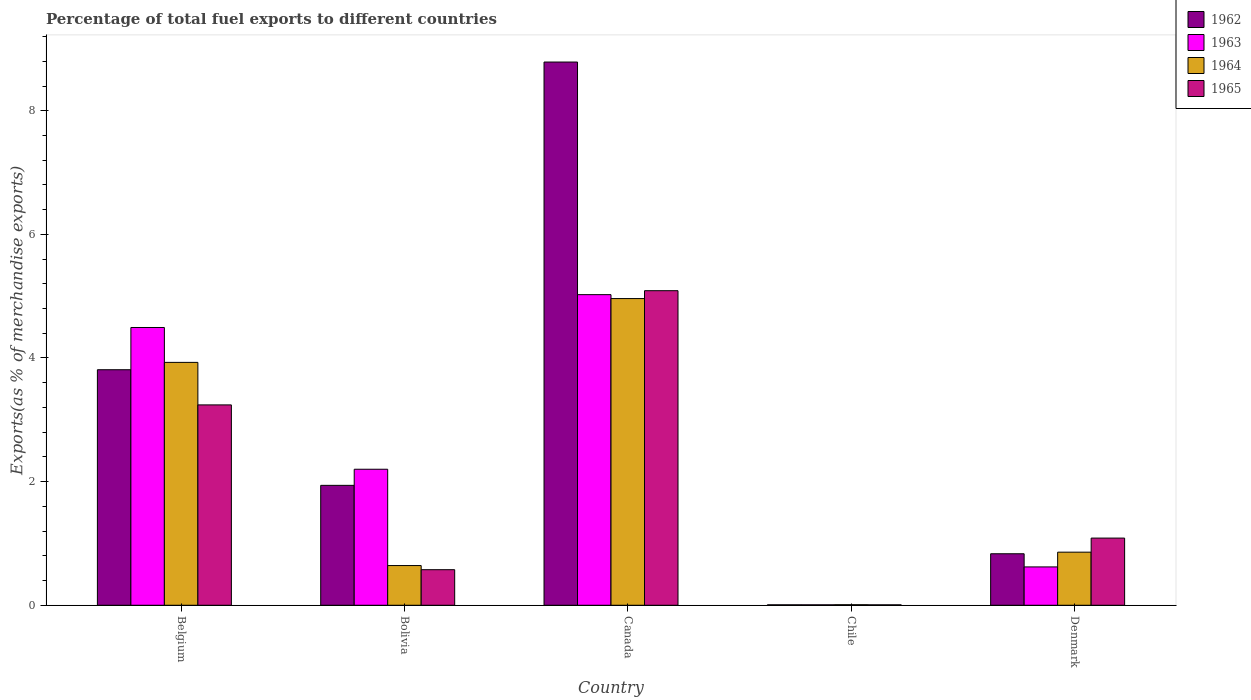How many different coloured bars are there?
Your answer should be compact. 4. How many groups of bars are there?
Your response must be concise. 5. Are the number of bars per tick equal to the number of legend labels?
Give a very brief answer. Yes. How many bars are there on the 2nd tick from the left?
Provide a succinct answer. 4. In how many cases, is the number of bars for a given country not equal to the number of legend labels?
Keep it short and to the point. 0. What is the percentage of exports to different countries in 1964 in Chile?
Offer a very short reply. 0.01. Across all countries, what is the maximum percentage of exports to different countries in 1964?
Your answer should be very brief. 4.96. Across all countries, what is the minimum percentage of exports to different countries in 1964?
Your response must be concise. 0.01. What is the total percentage of exports to different countries in 1963 in the graph?
Provide a short and direct response. 12.35. What is the difference between the percentage of exports to different countries in 1965 in Canada and that in Chile?
Offer a very short reply. 5.08. What is the difference between the percentage of exports to different countries in 1963 in Bolivia and the percentage of exports to different countries in 1964 in Denmark?
Your answer should be very brief. 1.34. What is the average percentage of exports to different countries in 1964 per country?
Give a very brief answer. 2.08. What is the difference between the percentage of exports to different countries of/in 1963 and percentage of exports to different countries of/in 1962 in Chile?
Offer a terse response. 7.908928153989043e-5. What is the ratio of the percentage of exports to different countries in 1964 in Belgium to that in Bolivia?
Your response must be concise. 6.12. Is the percentage of exports to different countries in 1962 in Belgium less than that in Bolivia?
Your answer should be very brief. No. What is the difference between the highest and the second highest percentage of exports to different countries in 1962?
Keep it short and to the point. 6.85. What is the difference between the highest and the lowest percentage of exports to different countries in 1964?
Ensure brevity in your answer.  4.95. Is the sum of the percentage of exports to different countries in 1962 in Bolivia and Canada greater than the maximum percentage of exports to different countries in 1964 across all countries?
Make the answer very short. Yes. How many countries are there in the graph?
Offer a very short reply. 5. Does the graph contain any zero values?
Ensure brevity in your answer.  No. Does the graph contain grids?
Provide a succinct answer. No. Where does the legend appear in the graph?
Provide a succinct answer. Top right. How many legend labels are there?
Provide a succinct answer. 4. What is the title of the graph?
Your answer should be very brief. Percentage of total fuel exports to different countries. What is the label or title of the X-axis?
Offer a very short reply. Country. What is the label or title of the Y-axis?
Offer a very short reply. Exports(as % of merchandise exports). What is the Exports(as % of merchandise exports) of 1962 in Belgium?
Offer a very short reply. 3.81. What is the Exports(as % of merchandise exports) in 1963 in Belgium?
Make the answer very short. 4.49. What is the Exports(as % of merchandise exports) in 1964 in Belgium?
Your answer should be compact. 3.93. What is the Exports(as % of merchandise exports) of 1965 in Belgium?
Keep it short and to the point. 3.24. What is the Exports(as % of merchandise exports) in 1962 in Bolivia?
Give a very brief answer. 1.94. What is the Exports(as % of merchandise exports) of 1963 in Bolivia?
Ensure brevity in your answer.  2.2. What is the Exports(as % of merchandise exports) of 1964 in Bolivia?
Make the answer very short. 0.64. What is the Exports(as % of merchandise exports) of 1965 in Bolivia?
Ensure brevity in your answer.  0.58. What is the Exports(as % of merchandise exports) of 1962 in Canada?
Give a very brief answer. 8.79. What is the Exports(as % of merchandise exports) in 1963 in Canada?
Provide a short and direct response. 5.02. What is the Exports(as % of merchandise exports) of 1964 in Canada?
Your response must be concise. 4.96. What is the Exports(as % of merchandise exports) of 1965 in Canada?
Offer a terse response. 5.09. What is the Exports(as % of merchandise exports) in 1962 in Chile?
Ensure brevity in your answer.  0.01. What is the Exports(as % of merchandise exports) of 1963 in Chile?
Keep it short and to the point. 0.01. What is the Exports(as % of merchandise exports) of 1964 in Chile?
Provide a succinct answer. 0.01. What is the Exports(as % of merchandise exports) of 1965 in Chile?
Offer a very short reply. 0.01. What is the Exports(as % of merchandise exports) in 1962 in Denmark?
Your response must be concise. 0.83. What is the Exports(as % of merchandise exports) in 1963 in Denmark?
Offer a terse response. 0.62. What is the Exports(as % of merchandise exports) of 1964 in Denmark?
Make the answer very short. 0.86. What is the Exports(as % of merchandise exports) in 1965 in Denmark?
Offer a very short reply. 1.09. Across all countries, what is the maximum Exports(as % of merchandise exports) of 1962?
Offer a terse response. 8.79. Across all countries, what is the maximum Exports(as % of merchandise exports) in 1963?
Make the answer very short. 5.02. Across all countries, what is the maximum Exports(as % of merchandise exports) in 1964?
Ensure brevity in your answer.  4.96. Across all countries, what is the maximum Exports(as % of merchandise exports) in 1965?
Keep it short and to the point. 5.09. Across all countries, what is the minimum Exports(as % of merchandise exports) in 1962?
Provide a short and direct response. 0.01. Across all countries, what is the minimum Exports(as % of merchandise exports) of 1963?
Provide a short and direct response. 0.01. Across all countries, what is the minimum Exports(as % of merchandise exports) of 1964?
Make the answer very short. 0.01. Across all countries, what is the minimum Exports(as % of merchandise exports) in 1965?
Your response must be concise. 0.01. What is the total Exports(as % of merchandise exports) of 1962 in the graph?
Give a very brief answer. 15.38. What is the total Exports(as % of merchandise exports) in 1963 in the graph?
Provide a short and direct response. 12.35. What is the total Exports(as % of merchandise exports) of 1964 in the graph?
Ensure brevity in your answer.  10.4. What is the total Exports(as % of merchandise exports) in 1965 in the graph?
Make the answer very short. 10. What is the difference between the Exports(as % of merchandise exports) of 1962 in Belgium and that in Bolivia?
Provide a short and direct response. 1.87. What is the difference between the Exports(as % of merchandise exports) of 1963 in Belgium and that in Bolivia?
Offer a very short reply. 2.29. What is the difference between the Exports(as % of merchandise exports) in 1964 in Belgium and that in Bolivia?
Your response must be concise. 3.29. What is the difference between the Exports(as % of merchandise exports) of 1965 in Belgium and that in Bolivia?
Provide a succinct answer. 2.67. What is the difference between the Exports(as % of merchandise exports) in 1962 in Belgium and that in Canada?
Keep it short and to the point. -4.98. What is the difference between the Exports(as % of merchandise exports) in 1963 in Belgium and that in Canada?
Ensure brevity in your answer.  -0.53. What is the difference between the Exports(as % of merchandise exports) of 1964 in Belgium and that in Canada?
Keep it short and to the point. -1.03. What is the difference between the Exports(as % of merchandise exports) in 1965 in Belgium and that in Canada?
Give a very brief answer. -1.85. What is the difference between the Exports(as % of merchandise exports) in 1962 in Belgium and that in Chile?
Your answer should be compact. 3.8. What is the difference between the Exports(as % of merchandise exports) of 1963 in Belgium and that in Chile?
Give a very brief answer. 4.49. What is the difference between the Exports(as % of merchandise exports) in 1964 in Belgium and that in Chile?
Give a very brief answer. 3.92. What is the difference between the Exports(as % of merchandise exports) in 1965 in Belgium and that in Chile?
Make the answer very short. 3.23. What is the difference between the Exports(as % of merchandise exports) of 1962 in Belgium and that in Denmark?
Your answer should be very brief. 2.98. What is the difference between the Exports(as % of merchandise exports) in 1963 in Belgium and that in Denmark?
Offer a very short reply. 3.87. What is the difference between the Exports(as % of merchandise exports) in 1964 in Belgium and that in Denmark?
Ensure brevity in your answer.  3.07. What is the difference between the Exports(as % of merchandise exports) in 1965 in Belgium and that in Denmark?
Your answer should be compact. 2.15. What is the difference between the Exports(as % of merchandise exports) of 1962 in Bolivia and that in Canada?
Provide a succinct answer. -6.85. What is the difference between the Exports(as % of merchandise exports) of 1963 in Bolivia and that in Canada?
Give a very brief answer. -2.82. What is the difference between the Exports(as % of merchandise exports) of 1964 in Bolivia and that in Canada?
Your answer should be very brief. -4.32. What is the difference between the Exports(as % of merchandise exports) in 1965 in Bolivia and that in Canada?
Give a very brief answer. -4.51. What is the difference between the Exports(as % of merchandise exports) in 1962 in Bolivia and that in Chile?
Offer a very short reply. 1.93. What is the difference between the Exports(as % of merchandise exports) in 1963 in Bolivia and that in Chile?
Offer a very short reply. 2.19. What is the difference between the Exports(as % of merchandise exports) in 1964 in Bolivia and that in Chile?
Offer a terse response. 0.63. What is the difference between the Exports(as % of merchandise exports) in 1965 in Bolivia and that in Chile?
Make the answer very short. 0.57. What is the difference between the Exports(as % of merchandise exports) of 1962 in Bolivia and that in Denmark?
Provide a succinct answer. 1.11. What is the difference between the Exports(as % of merchandise exports) of 1963 in Bolivia and that in Denmark?
Provide a short and direct response. 1.58. What is the difference between the Exports(as % of merchandise exports) in 1964 in Bolivia and that in Denmark?
Provide a short and direct response. -0.22. What is the difference between the Exports(as % of merchandise exports) in 1965 in Bolivia and that in Denmark?
Provide a short and direct response. -0.51. What is the difference between the Exports(as % of merchandise exports) in 1962 in Canada and that in Chile?
Provide a short and direct response. 8.78. What is the difference between the Exports(as % of merchandise exports) in 1963 in Canada and that in Chile?
Provide a short and direct response. 5.02. What is the difference between the Exports(as % of merchandise exports) of 1964 in Canada and that in Chile?
Make the answer very short. 4.95. What is the difference between the Exports(as % of merchandise exports) of 1965 in Canada and that in Chile?
Keep it short and to the point. 5.08. What is the difference between the Exports(as % of merchandise exports) in 1962 in Canada and that in Denmark?
Make the answer very short. 7.95. What is the difference between the Exports(as % of merchandise exports) of 1963 in Canada and that in Denmark?
Make the answer very short. 4.4. What is the difference between the Exports(as % of merchandise exports) in 1964 in Canada and that in Denmark?
Give a very brief answer. 4.1. What is the difference between the Exports(as % of merchandise exports) in 1965 in Canada and that in Denmark?
Your answer should be compact. 4. What is the difference between the Exports(as % of merchandise exports) of 1962 in Chile and that in Denmark?
Provide a short and direct response. -0.83. What is the difference between the Exports(as % of merchandise exports) of 1963 in Chile and that in Denmark?
Offer a terse response. -0.61. What is the difference between the Exports(as % of merchandise exports) in 1964 in Chile and that in Denmark?
Provide a short and direct response. -0.85. What is the difference between the Exports(as % of merchandise exports) in 1965 in Chile and that in Denmark?
Your response must be concise. -1.08. What is the difference between the Exports(as % of merchandise exports) in 1962 in Belgium and the Exports(as % of merchandise exports) in 1963 in Bolivia?
Offer a terse response. 1.61. What is the difference between the Exports(as % of merchandise exports) of 1962 in Belgium and the Exports(as % of merchandise exports) of 1964 in Bolivia?
Ensure brevity in your answer.  3.17. What is the difference between the Exports(as % of merchandise exports) of 1962 in Belgium and the Exports(as % of merchandise exports) of 1965 in Bolivia?
Provide a short and direct response. 3.23. What is the difference between the Exports(as % of merchandise exports) in 1963 in Belgium and the Exports(as % of merchandise exports) in 1964 in Bolivia?
Offer a very short reply. 3.85. What is the difference between the Exports(as % of merchandise exports) of 1963 in Belgium and the Exports(as % of merchandise exports) of 1965 in Bolivia?
Make the answer very short. 3.92. What is the difference between the Exports(as % of merchandise exports) in 1964 in Belgium and the Exports(as % of merchandise exports) in 1965 in Bolivia?
Provide a short and direct response. 3.35. What is the difference between the Exports(as % of merchandise exports) of 1962 in Belgium and the Exports(as % of merchandise exports) of 1963 in Canada?
Make the answer very short. -1.21. What is the difference between the Exports(as % of merchandise exports) in 1962 in Belgium and the Exports(as % of merchandise exports) in 1964 in Canada?
Offer a terse response. -1.15. What is the difference between the Exports(as % of merchandise exports) in 1962 in Belgium and the Exports(as % of merchandise exports) in 1965 in Canada?
Keep it short and to the point. -1.28. What is the difference between the Exports(as % of merchandise exports) of 1963 in Belgium and the Exports(as % of merchandise exports) of 1964 in Canada?
Keep it short and to the point. -0.47. What is the difference between the Exports(as % of merchandise exports) of 1963 in Belgium and the Exports(as % of merchandise exports) of 1965 in Canada?
Ensure brevity in your answer.  -0.6. What is the difference between the Exports(as % of merchandise exports) in 1964 in Belgium and the Exports(as % of merchandise exports) in 1965 in Canada?
Your response must be concise. -1.16. What is the difference between the Exports(as % of merchandise exports) in 1962 in Belgium and the Exports(as % of merchandise exports) in 1963 in Chile?
Provide a short and direct response. 3.8. What is the difference between the Exports(as % of merchandise exports) of 1962 in Belgium and the Exports(as % of merchandise exports) of 1964 in Chile?
Offer a very short reply. 3.8. What is the difference between the Exports(as % of merchandise exports) of 1962 in Belgium and the Exports(as % of merchandise exports) of 1965 in Chile?
Ensure brevity in your answer.  3.8. What is the difference between the Exports(as % of merchandise exports) in 1963 in Belgium and the Exports(as % of merchandise exports) in 1964 in Chile?
Ensure brevity in your answer.  4.48. What is the difference between the Exports(as % of merchandise exports) in 1963 in Belgium and the Exports(as % of merchandise exports) in 1965 in Chile?
Keep it short and to the point. 4.49. What is the difference between the Exports(as % of merchandise exports) of 1964 in Belgium and the Exports(as % of merchandise exports) of 1965 in Chile?
Your response must be concise. 3.92. What is the difference between the Exports(as % of merchandise exports) of 1962 in Belgium and the Exports(as % of merchandise exports) of 1963 in Denmark?
Your answer should be compact. 3.19. What is the difference between the Exports(as % of merchandise exports) of 1962 in Belgium and the Exports(as % of merchandise exports) of 1964 in Denmark?
Give a very brief answer. 2.95. What is the difference between the Exports(as % of merchandise exports) of 1962 in Belgium and the Exports(as % of merchandise exports) of 1965 in Denmark?
Keep it short and to the point. 2.72. What is the difference between the Exports(as % of merchandise exports) in 1963 in Belgium and the Exports(as % of merchandise exports) in 1964 in Denmark?
Keep it short and to the point. 3.63. What is the difference between the Exports(as % of merchandise exports) of 1963 in Belgium and the Exports(as % of merchandise exports) of 1965 in Denmark?
Your response must be concise. 3.41. What is the difference between the Exports(as % of merchandise exports) of 1964 in Belgium and the Exports(as % of merchandise exports) of 1965 in Denmark?
Offer a terse response. 2.84. What is the difference between the Exports(as % of merchandise exports) in 1962 in Bolivia and the Exports(as % of merchandise exports) in 1963 in Canada?
Keep it short and to the point. -3.08. What is the difference between the Exports(as % of merchandise exports) of 1962 in Bolivia and the Exports(as % of merchandise exports) of 1964 in Canada?
Provide a short and direct response. -3.02. What is the difference between the Exports(as % of merchandise exports) of 1962 in Bolivia and the Exports(as % of merchandise exports) of 1965 in Canada?
Make the answer very short. -3.15. What is the difference between the Exports(as % of merchandise exports) in 1963 in Bolivia and the Exports(as % of merchandise exports) in 1964 in Canada?
Your answer should be very brief. -2.76. What is the difference between the Exports(as % of merchandise exports) of 1963 in Bolivia and the Exports(as % of merchandise exports) of 1965 in Canada?
Your response must be concise. -2.89. What is the difference between the Exports(as % of merchandise exports) of 1964 in Bolivia and the Exports(as % of merchandise exports) of 1965 in Canada?
Your response must be concise. -4.45. What is the difference between the Exports(as % of merchandise exports) of 1962 in Bolivia and the Exports(as % of merchandise exports) of 1963 in Chile?
Give a very brief answer. 1.93. What is the difference between the Exports(as % of merchandise exports) in 1962 in Bolivia and the Exports(as % of merchandise exports) in 1964 in Chile?
Make the answer very short. 1.93. What is the difference between the Exports(as % of merchandise exports) in 1962 in Bolivia and the Exports(as % of merchandise exports) in 1965 in Chile?
Keep it short and to the point. 1.93. What is the difference between the Exports(as % of merchandise exports) in 1963 in Bolivia and the Exports(as % of merchandise exports) in 1964 in Chile?
Your response must be concise. 2.19. What is the difference between the Exports(as % of merchandise exports) in 1963 in Bolivia and the Exports(as % of merchandise exports) in 1965 in Chile?
Offer a very short reply. 2.19. What is the difference between the Exports(as % of merchandise exports) of 1964 in Bolivia and the Exports(as % of merchandise exports) of 1965 in Chile?
Your response must be concise. 0.64. What is the difference between the Exports(as % of merchandise exports) of 1962 in Bolivia and the Exports(as % of merchandise exports) of 1963 in Denmark?
Your answer should be very brief. 1.32. What is the difference between the Exports(as % of merchandise exports) in 1962 in Bolivia and the Exports(as % of merchandise exports) in 1964 in Denmark?
Your answer should be very brief. 1.08. What is the difference between the Exports(as % of merchandise exports) in 1962 in Bolivia and the Exports(as % of merchandise exports) in 1965 in Denmark?
Give a very brief answer. 0.85. What is the difference between the Exports(as % of merchandise exports) of 1963 in Bolivia and the Exports(as % of merchandise exports) of 1964 in Denmark?
Your response must be concise. 1.34. What is the difference between the Exports(as % of merchandise exports) in 1963 in Bolivia and the Exports(as % of merchandise exports) in 1965 in Denmark?
Your answer should be compact. 1.11. What is the difference between the Exports(as % of merchandise exports) in 1964 in Bolivia and the Exports(as % of merchandise exports) in 1965 in Denmark?
Your response must be concise. -0.44. What is the difference between the Exports(as % of merchandise exports) of 1962 in Canada and the Exports(as % of merchandise exports) of 1963 in Chile?
Make the answer very short. 8.78. What is the difference between the Exports(as % of merchandise exports) of 1962 in Canada and the Exports(as % of merchandise exports) of 1964 in Chile?
Make the answer very short. 8.78. What is the difference between the Exports(as % of merchandise exports) in 1962 in Canada and the Exports(as % of merchandise exports) in 1965 in Chile?
Give a very brief answer. 8.78. What is the difference between the Exports(as % of merchandise exports) of 1963 in Canada and the Exports(as % of merchandise exports) of 1964 in Chile?
Your answer should be compact. 5.02. What is the difference between the Exports(as % of merchandise exports) of 1963 in Canada and the Exports(as % of merchandise exports) of 1965 in Chile?
Make the answer very short. 5.02. What is the difference between the Exports(as % of merchandise exports) in 1964 in Canada and the Exports(as % of merchandise exports) in 1965 in Chile?
Offer a very short reply. 4.95. What is the difference between the Exports(as % of merchandise exports) in 1962 in Canada and the Exports(as % of merchandise exports) in 1963 in Denmark?
Offer a terse response. 8.17. What is the difference between the Exports(as % of merchandise exports) of 1962 in Canada and the Exports(as % of merchandise exports) of 1964 in Denmark?
Provide a succinct answer. 7.93. What is the difference between the Exports(as % of merchandise exports) in 1962 in Canada and the Exports(as % of merchandise exports) in 1965 in Denmark?
Provide a succinct answer. 7.7. What is the difference between the Exports(as % of merchandise exports) of 1963 in Canada and the Exports(as % of merchandise exports) of 1964 in Denmark?
Keep it short and to the point. 4.17. What is the difference between the Exports(as % of merchandise exports) in 1963 in Canada and the Exports(as % of merchandise exports) in 1965 in Denmark?
Make the answer very short. 3.94. What is the difference between the Exports(as % of merchandise exports) of 1964 in Canada and the Exports(as % of merchandise exports) of 1965 in Denmark?
Your response must be concise. 3.87. What is the difference between the Exports(as % of merchandise exports) of 1962 in Chile and the Exports(as % of merchandise exports) of 1963 in Denmark?
Provide a short and direct response. -0.61. What is the difference between the Exports(as % of merchandise exports) of 1962 in Chile and the Exports(as % of merchandise exports) of 1964 in Denmark?
Your response must be concise. -0.85. What is the difference between the Exports(as % of merchandise exports) of 1962 in Chile and the Exports(as % of merchandise exports) of 1965 in Denmark?
Keep it short and to the point. -1.08. What is the difference between the Exports(as % of merchandise exports) in 1963 in Chile and the Exports(as % of merchandise exports) in 1964 in Denmark?
Your answer should be very brief. -0.85. What is the difference between the Exports(as % of merchandise exports) of 1963 in Chile and the Exports(as % of merchandise exports) of 1965 in Denmark?
Give a very brief answer. -1.08. What is the difference between the Exports(as % of merchandise exports) in 1964 in Chile and the Exports(as % of merchandise exports) in 1965 in Denmark?
Your answer should be very brief. -1.08. What is the average Exports(as % of merchandise exports) in 1962 per country?
Keep it short and to the point. 3.08. What is the average Exports(as % of merchandise exports) of 1963 per country?
Your response must be concise. 2.47. What is the average Exports(as % of merchandise exports) of 1964 per country?
Ensure brevity in your answer.  2.08. What is the average Exports(as % of merchandise exports) in 1965 per country?
Offer a very short reply. 2. What is the difference between the Exports(as % of merchandise exports) in 1962 and Exports(as % of merchandise exports) in 1963 in Belgium?
Provide a succinct answer. -0.68. What is the difference between the Exports(as % of merchandise exports) of 1962 and Exports(as % of merchandise exports) of 1964 in Belgium?
Ensure brevity in your answer.  -0.12. What is the difference between the Exports(as % of merchandise exports) in 1962 and Exports(as % of merchandise exports) in 1965 in Belgium?
Provide a succinct answer. 0.57. What is the difference between the Exports(as % of merchandise exports) of 1963 and Exports(as % of merchandise exports) of 1964 in Belgium?
Offer a very short reply. 0.56. What is the difference between the Exports(as % of merchandise exports) of 1963 and Exports(as % of merchandise exports) of 1965 in Belgium?
Ensure brevity in your answer.  1.25. What is the difference between the Exports(as % of merchandise exports) of 1964 and Exports(as % of merchandise exports) of 1965 in Belgium?
Provide a short and direct response. 0.69. What is the difference between the Exports(as % of merchandise exports) in 1962 and Exports(as % of merchandise exports) in 1963 in Bolivia?
Provide a short and direct response. -0.26. What is the difference between the Exports(as % of merchandise exports) of 1962 and Exports(as % of merchandise exports) of 1964 in Bolivia?
Ensure brevity in your answer.  1.3. What is the difference between the Exports(as % of merchandise exports) in 1962 and Exports(as % of merchandise exports) in 1965 in Bolivia?
Your answer should be compact. 1.36. What is the difference between the Exports(as % of merchandise exports) in 1963 and Exports(as % of merchandise exports) in 1964 in Bolivia?
Make the answer very short. 1.56. What is the difference between the Exports(as % of merchandise exports) of 1963 and Exports(as % of merchandise exports) of 1965 in Bolivia?
Keep it short and to the point. 1.62. What is the difference between the Exports(as % of merchandise exports) in 1964 and Exports(as % of merchandise exports) in 1965 in Bolivia?
Your answer should be very brief. 0.07. What is the difference between the Exports(as % of merchandise exports) of 1962 and Exports(as % of merchandise exports) of 1963 in Canada?
Offer a terse response. 3.76. What is the difference between the Exports(as % of merchandise exports) of 1962 and Exports(as % of merchandise exports) of 1964 in Canada?
Make the answer very short. 3.83. What is the difference between the Exports(as % of merchandise exports) of 1962 and Exports(as % of merchandise exports) of 1965 in Canada?
Provide a succinct answer. 3.7. What is the difference between the Exports(as % of merchandise exports) in 1963 and Exports(as % of merchandise exports) in 1964 in Canada?
Offer a very short reply. 0.06. What is the difference between the Exports(as % of merchandise exports) in 1963 and Exports(as % of merchandise exports) in 1965 in Canada?
Give a very brief answer. -0.06. What is the difference between the Exports(as % of merchandise exports) in 1964 and Exports(as % of merchandise exports) in 1965 in Canada?
Make the answer very short. -0.13. What is the difference between the Exports(as % of merchandise exports) of 1962 and Exports(as % of merchandise exports) of 1963 in Chile?
Make the answer very short. -0. What is the difference between the Exports(as % of merchandise exports) in 1962 and Exports(as % of merchandise exports) in 1964 in Chile?
Give a very brief answer. -0. What is the difference between the Exports(as % of merchandise exports) in 1962 and Exports(as % of merchandise exports) in 1965 in Chile?
Provide a succinct answer. 0. What is the difference between the Exports(as % of merchandise exports) in 1963 and Exports(as % of merchandise exports) in 1964 in Chile?
Ensure brevity in your answer.  -0. What is the difference between the Exports(as % of merchandise exports) in 1964 and Exports(as % of merchandise exports) in 1965 in Chile?
Provide a succinct answer. 0. What is the difference between the Exports(as % of merchandise exports) in 1962 and Exports(as % of merchandise exports) in 1963 in Denmark?
Keep it short and to the point. 0.21. What is the difference between the Exports(as % of merchandise exports) of 1962 and Exports(as % of merchandise exports) of 1964 in Denmark?
Offer a very short reply. -0.03. What is the difference between the Exports(as % of merchandise exports) in 1962 and Exports(as % of merchandise exports) in 1965 in Denmark?
Your answer should be compact. -0.25. What is the difference between the Exports(as % of merchandise exports) in 1963 and Exports(as % of merchandise exports) in 1964 in Denmark?
Your answer should be compact. -0.24. What is the difference between the Exports(as % of merchandise exports) in 1963 and Exports(as % of merchandise exports) in 1965 in Denmark?
Provide a short and direct response. -0.47. What is the difference between the Exports(as % of merchandise exports) of 1964 and Exports(as % of merchandise exports) of 1965 in Denmark?
Provide a short and direct response. -0.23. What is the ratio of the Exports(as % of merchandise exports) in 1962 in Belgium to that in Bolivia?
Your answer should be very brief. 1.96. What is the ratio of the Exports(as % of merchandise exports) in 1963 in Belgium to that in Bolivia?
Give a very brief answer. 2.04. What is the ratio of the Exports(as % of merchandise exports) of 1964 in Belgium to that in Bolivia?
Provide a succinct answer. 6.12. What is the ratio of the Exports(as % of merchandise exports) of 1965 in Belgium to that in Bolivia?
Offer a terse response. 5.63. What is the ratio of the Exports(as % of merchandise exports) of 1962 in Belgium to that in Canada?
Make the answer very short. 0.43. What is the ratio of the Exports(as % of merchandise exports) of 1963 in Belgium to that in Canada?
Provide a succinct answer. 0.89. What is the ratio of the Exports(as % of merchandise exports) of 1964 in Belgium to that in Canada?
Offer a very short reply. 0.79. What is the ratio of the Exports(as % of merchandise exports) of 1965 in Belgium to that in Canada?
Make the answer very short. 0.64. What is the ratio of the Exports(as % of merchandise exports) of 1962 in Belgium to that in Chile?
Give a very brief answer. 543.89. What is the ratio of the Exports(as % of merchandise exports) of 1963 in Belgium to that in Chile?
Ensure brevity in your answer.  634.23. What is the ratio of the Exports(as % of merchandise exports) of 1964 in Belgium to that in Chile?
Keep it short and to the point. 439.88. What is the ratio of the Exports(as % of merchandise exports) of 1965 in Belgium to that in Chile?
Keep it short and to the point. 479.5. What is the ratio of the Exports(as % of merchandise exports) in 1962 in Belgium to that in Denmark?
Provide a short and direct response. 4.57. What is the ratio of the Exports(as % of merchandise exports) in 1963 in Belgium to that in Denmark?
Give a very brief answer. 7.24. What is the ratio of the Exports(as % of merchandise exports) in 1964 in Belgium to that in Denmark?
Offer a very short reply. 4.57. What is the ratio of the Exports(as % of merchandise exports) of 1965 in Belgium to that in Denmark?
Your answer should be compact. 2.98. What is the ratio of the Exports(as % of merchandise exports) of 1962 in Bolivia to that in Canada?
Give a very brief answer. 0.22. What is the ratio of the Exports(as % of merchandise exports) of 1963 in Bolivia to that in Canada?
Your response must be concise. 0.44. What is the ratio of the Exports(as % of merchandise exports) of 1964 in Bolivia to that in Canada?
Your answer should be compact. 0.13. What is the ratio of the Exports(as % of merchandise exports) of 1965 in Bolivia to that in Canada?
Your response must be concise. 0.11. What is the ratio of the Exports(as % of merchandise exports) in 1962 in Bolivia to that in Chile?
Offer a very short reply. 276.87. What is the ratio of the Exports(as % of merchandise exports) in 1963 in Bolivia to that in Chile?
Provide a succinct answer. 310.59. What is the ratio of the Exports(as % of merchandise exports) in 1964 in Bolivia to that in Chile?
Your answer should be compact. 71.92. What is the ratio of the Exports(as % of merchandise exports) of 1965 in Bolivia to that in Chile?
Offer a terse response. 85.13. What is the ratio of the Exports(as % of merchandise exports) in 1962 in Bolivia to that in Denmark?
Ensure brevity in your answer.  2.33. What is the ratio of the Exports(as % of merchandise exports) of 1963 in Bolivia to that in Denmark?
Your answer should be compact. 3.55. What is the ratio of the Exports(as % of merchandise exports) of 1964 in Bolivia to that in Denmark?
Ensure brevity in your answer.  0.75. What is the ratio of the Exports(as % of merchandise exports) of 1965 in Bolivia to that in Denmark?
Keep it short and to the point. 0.53. What is the ratio of the Exports(as % of merchandise exports) of 1962 in Canada to that in Chile?
Give a very brief answer. 1254.38. What is the ratio of the Exports(as % of merchandise exports) in 1963 in Canada to that in Chile?
Provide a succinct answer. 709.22. What is the ratio of the Exports(as % of merchandise exports) in 1964 in Canada to that in Chile?
Offer a very short reply. 555.45. What is the ratio of the Exports(as % of merchandise exports) in 1965 in Canada to that in Chile?
Your answer should be very brief. 752.83. What is the ratio of the Exports(as % of merchandise exports) of 1962 in Canada to that in Denmark?
Make the answer very short. 10.55. What is the ratio of the Exports(as % of merchandise exports) of 1963 in Canada to that in Denmark?
Your answer should be very brief. 8.1. What is the ratio of the Exports(as % of merchandise exports) in 1964 in Canada to that in Denmark?
Keep it short and to the point. 5.78. What is the ratio of the Exports(as % of merchandise exports) of 1965 in Canada to that in Denmark?
Your answer should be compact. 4.68. What is the ratio of the Exports(as % of merchandise exports) of 1962 in Chile to that in Denmark?
Provide a succinct answer. 0.01. What is the ratio of the Exports(as % of merchandise exports) in 1963 in Chile to that in Denmark?
Offer a very short reply. 0.01. What is the ratio of the Exports(as % of merchandise exports) of 1964 in Chile to that in Denmark?
Your answer should be compact. 0.01. What is the ratio of the Exports(as % of merchandise exports) in 1965 in Chile to that in Denmark?
Your answer should be compact. 0.01. What is the difference between the highest and the second highest Exports(as % of merchandise exports) in 1962?
Give a very brief answer. 4.98. What is the difference between the highest and the second highest Exports(as % of merchandise exports) of 1963?
Provide a succinct answer. 0.53. What is the difference between the highest and the second highest Exports(as % of merchandise exports) in 1964?
Your response must be concise. 1.03. What is the difference between the highest and the second highest Exports(as % of merchandise exports) in 1965?
Your answer should be very brief. 1.85. What is the difference between the highest and the lowest Exports(as % of merchandise exports) of 1962?
Your answer should be very brief. 8.78. What is the difference between the highest and the lowest Exports(as % of merchandise exports) of 1963?
Provide a succinct answer. 5.02. What is the difference between the highest and the lowest Exports(as % of merchandise exports) of 1964?
Ensure brevity in your answer.  4.95. What is the difference between the highest and the lowest Exports(as % of merchandise exports) in 1965?
Provide a succinct answer. 5.08. 